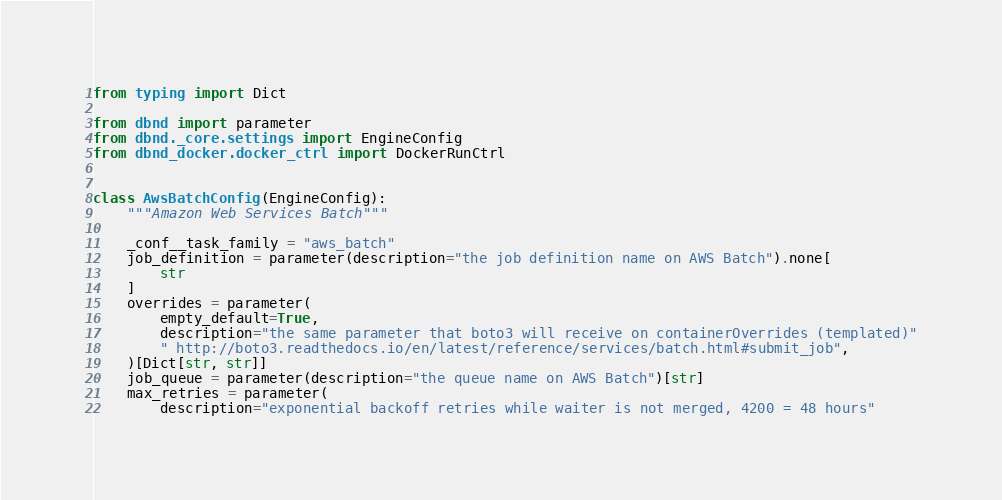<code> <loc_0><loc_0><loc_500><loc_500><_Python_>from typing import Dict

from dbnd import parameter
from dbnd._core.settings import EngineConfig
from dbnd_docker.docker_ctrl import DockerRunCtrl


class AwsBatchConfig(EngineConfig):
    """Amazon Web Services Batch"""

    _conf__task_family = "aws_batch"
    job_definition = parameter(description="the job definition name on AWS Batch").none[
        str
    ]
    overrides = parameter(
        empty_default=True,
        description="the same parameter that boto3 will receive on containerOverrides (templated)"
        " http://boto3.readthedocs.io/en/latest/reference/services/batch.html#submit_job",
    )[Dict[str, str]]
    job_queue = parameter(description="the queue name on AWS Batch")[str]
    max_retries = parameter(
        description="exponential backoff retries while waiter is not merged, 4200 = 48 hours"</code> 